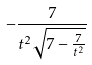Convert formula to latex. <formula><loc_0><loc_0><loc_500><loc_500>- \frac { 7 } { t ^ { 2 } \sqrt { 7 - \frac { 7 } { t ^ { 2 } } } }</formula> 